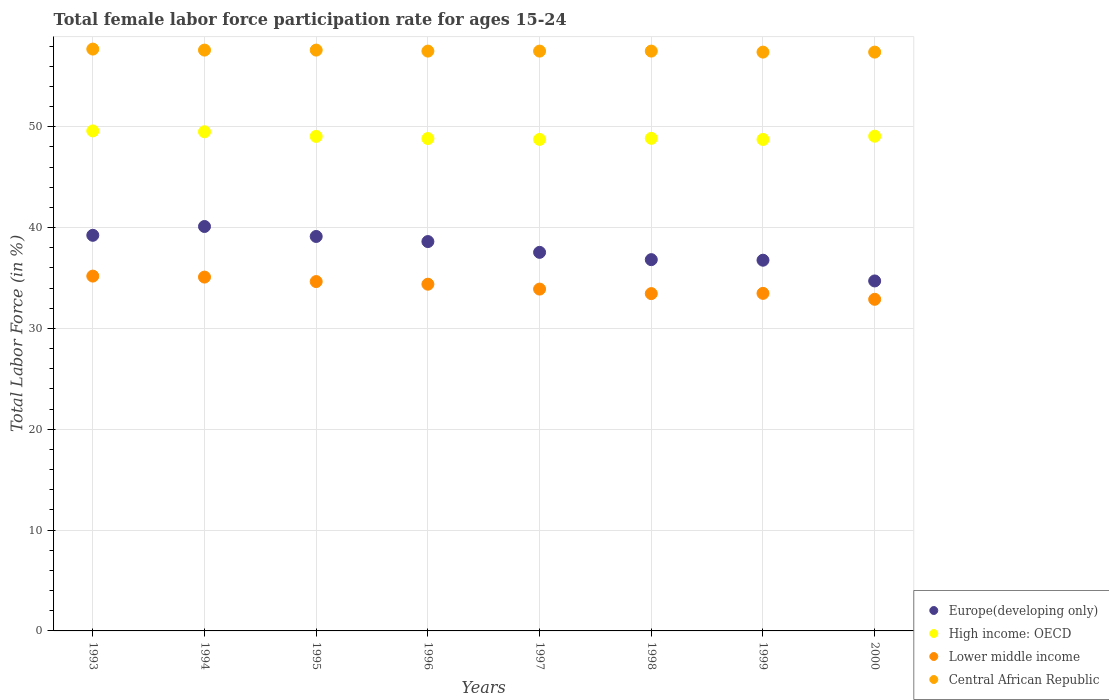Is the number of dotlines equal to the number of legend labels?
Give a very brief answer. Yes. What is the female labor force participation rate in High income: OECD in 1993?
Keep it short and to the point. 49.59. Across all years, what is the maximum female labor force participation rate in High income: OECD?
Offer a terse response. 49.59. Across all years, what is the minimum female labor force participation rate in Lower middle income?
Your answer should be very brief. 32.89. In which year was the female labor force participation rate in Central African Republic minimum?
Give a very brief answer. 1999. What is the total female labor force participation rate in High income: OECD in the graph?
Your answer should be compact. 392.35. What is the difference between the female labor force participation rate in Lower middle income in 1994 and that in 1996?
Your answer should be compact. 0.7. What is the difference between the female labor force participation rate in Europe(developing only) in 1993 and the female labor force participation rate in Lower middle income in 1996?
Your answer should be very brief. 4.85. What is the average female labor force participation rate in Europe(developing only) per year?
Keep it short and to the point. 37.86. In the year 1997, what is the difference between the female labor force participation rate in Lower middle income and female labor force participation rate in Central African Republic?
Your answer should be compact. -23.6. In how many years, is the female labor force participation rate in High income: OECD greater than 32 %?
Your answer should be very brief. 8. What is the ratio of the female labor force participation rate in Europe(developing only) in 1994 to that in 1996?
Provide a succinct answer. 1.04. Is the difference between the female labor force participation rate in Lower middle income in 1993 and 1996 greater than the difference between the female labor force participation rate in Central African Republic in 1993 and 1996?
Your response must be concise. Yes. What is the difference between the highest and the second highest female labor force participation rate in High income: OECD?
Ensure brevity in your answer.  0.08. What is the difference between the highest and the lowest female labor force participation rate in Lower middle income?
Your answer should be very brief. 2.3. In how many years, is the female labor force participation rate in Europe(developing only) greater than the average female labor force participation rate in Europe(developing only) taken over all years?
Make the answer very short. 4. Is it the case that in every year, the sum of the female labor force participation rate in Central African Republic and female labor force participation rate in Europe(developing only)  is greater than the female labor force participation rate in Lower middle income?
Ensure brevity in your answer.  Yes. Does the female labor force participation rate in Europe(developing only) monotonically increase over the years?
Ensure brevity in your answer.  No. Is the female labor force participation rate in Lower middle income strictly greater than the female labor force participation rate in Europe(developing only) over the years?
Give a very brief answer. No. Is the female labor force participation rate in Europe(developing only) strictly less than the female labor force participation rate in Central African Republic over the years?
Your answer should be compact. Yes. How many dotlines are there?
Your response must be concise. 4. Does the graph contain grids?
Provide a short and direct response. Yes. How are the legend labels stacked?
Keep it short and to the point. Vertical. What is the title of the graph?
Provide a short and direct response. Total female labor force participation rate for ages 15-24. Does "United Arab Emirates" appear as one of the legend labels in the graph?
Offer a very short reply. No. What is the Total Labor Force (in %) of Europe(developing only) in 1993?
Your response must be concise. 39.23. What is the Total Labor Force (in %) in High income: OECD in 1993?
Your response must be concise. 49.59. What is the Total Labor Force (in %) of Lower middle income in 1993?
Provide a short and direct response. 35.19. What is the Total Labor Force (in %) in Central African Republic in 1993?
Make the answer very short. 57.7. What is the Total Labor Force (in %) in Europe(developing only) in 1994?
Your answer should be very brief. 40.11. What is the Total Labor Force (in %) of High income: OECD in 1994?
Keep it short and to the point. 49.5. What is the Total Labor Force (in %) in Lower middle income in 1994?
Provide a succinct answer. 35.09. What is the Total Labor Force (in %) in Central African Republic in 1994?
Make the answer very short. 57.6. What is the Total Labor Force (in %) in Europe(developing only) in 1995?
Provide a succinct answer. 39.12. What is the Total Labor Force (in %) of High income: OECD in 1995?
Offer a terse response. 49.04. What is the Total Labor Force (in %) in Lower middle income in 1995?
Ensure brevity in your answer.  34.65. What is the Total Labor Force (in %) in Central African Republic in 1995?
Your answer should be compact. 57.6. What is the Total Labor Force (in %) of Europe(developing only) in 1996?
Your response must be concise. 38.61. What is the Total Labor Force (in %) in High income: OECD in 1996?
Your answer should be very brief. 48.83. What is the Total Labor Force (in %) in Lower middle income in 1996?
Your response must be concise. 34.38. What is the Total Labor Force (in %) of Central African Republic in 1996?
Provide a succinct answer. 57.5. What is the Total Labor Force (in %) of Europe(developing only) in 1997?
Ensure brevity in your answer.  37.54. What is the Total Labor Force (in %) in High income: OECD in 1997?
Provide a succinct answer. 48.74. What is the Total Labor Force (in %) in Lower middle income in 1997?
Ensure brevity in your answer.  33.9. What is the Total Labor Force (in %) in Central African Republic in 1997?
Offer a very short reply. 57.5. What is the Total Labor Force (in %) of Europe(developing only) in 1998?
Keep it short and to the point. 36.82. What is the Total Labor Force (in %) in High income: OECD in 1998?
Ensure brevity in your answer.  48.85. What is the Total Labor Force (in %) of Lower middle income in 1998?
Give a very brief answer. 33.45. What is the Total Labor Force (in %) of Central African Republic in 1998?
Make the answer very short. 57.5. What is the Total Labor Force (in %) in Europe(developing only) in 1999?
Ensure brevity in your answer.  36.76. What is the Total Labor Force (in %) in High income: OECD in 1999?
Ensure brevity in your answer.  48.74. What is the Total Labor Force (in %) of Lower middle income in 1999?
Make the answer very short. 33.48. What is the Total Labor Force (in %) in Central African Republic in 1999?
Make the answer very short. 57.4. What is the Total Labor Force (in %) of Europe(developing only) in 2000?
Offer a terse response. 34.71. What is the Total Labor Force (in %) in High income: OECD in 2000?
Offer a terse response. 49.06. What is the Total Labor Force (in %) of Lower middle income in 2000?
Your response must be concise. 32.89. What is the Total Labor Force (in %) in Central African Republic in 2000?
Offer a terse response. 57.4. Across all years, what is the maximum Total Labor Force (in %) of Europe(developing only)?
Give a very brief answer. 40.11. Across all years, what is the maximum Total Labor Force (in %) in High income: OECD?
Your answer should be compact. 49.59. Across all years, what is the maximum Total Labor Force (in %) in Lower middle income?
Provide a short and direct response. 35.19. Across all years, what is the maximum Total Labor Force (in %) in Central African Republic?
Offer a very short reply. 57.7. Across all years, what is the minimum Total Labor Force (in %) in Europe(developing only)?
Keep it short and to the point. 34.71. Across all years, what is the minimum Total Labor Force (in %) of High income: OECD?
Keep it short and to the point. 48.74. Across all years, what is the minimum Total Labor Force (in %) of Lower middle income?
Provide a succinct answer. 32.89. Across all years, what is the minimum Total Labor Force (in %) of Central African Republic?
Give a very brief answer. 57.4. What is the total Total Labor Force (in %) of Europe(developing only) in the graph?
Your answer should be very brief. 302.9. What is the total Total Labor Force (in %) in High income: OECD in the graph?
Provide a succinct answer. 392.35. What is the total Total Labor Force (in %) in Lower middle income in the graph?
Offer a very short reply. 273.02. What is the total Total Labor Force (in %) in Central African Republic in the graph?
Ensure brevity in your answer.  460.2. What is the difference between the Total Labor Force (in %) of Europe(developing only) in 1993 and that in 1994?
Your answer should be very brief. -0.87. What is the difference between the Total Labor Force (in %) of High income: OECD in 1993 and that in 1994?
Provide a short and direct response. 0.08. What is the difference between the Total Labor Force (in %) of Lower middle income in 1993 and that in 1994?
Give a very brief answer. 0.1. What is the difference between the Total Labor Force (in %) of Central African Republic in 1993 and that in 1994?
Your answer should be compact. 0.1. What is the difference between the Total Labor Force (in %) of Europe(developing only) in 1993 and that in 1995?
Your answer should be compact. 0.11. What is the difference between the Total Labor Force (in %) in High income: OECD in 1993 and that in 1995?
Offer a terse response. 0.55. What is the difference between the Total Labor Force (in %) of Lower middle income in 1993 and that in 1995?
Your answer should be compact. 0.54. What is the difference between the Total Labor Force (in %) in Central African Republic in 1993 and that in 1995?
Provide a short and direct response. 0.1. What is the difference between the Total Labor Force (in %) of Europe(developing only) in 1993 and that in 1996?
Give a very brief answer. 0.62. What is the difference between the Total Labor Force (in %) of High income: OECD in 1993 and that in 1996?
Provide a short and direct response. 0.76. What is the difference between the Total Labor Force (in %) in Lower middle income in 1993 and that in 1996?
Offer a terse response. 0.8. What is the difference between the Total Labor Force (in %) of Europe(developing only) in 1993 and that in 1997?
Give a very brief answer. 1.69. What is the difference between the Total Labor Force (in %) in High income: OECD in 1993 and that in 1997?
Give a very brief answer. 0.84. What is the difference between the Total Labor Force (in %) of Lower middle income in 1993 and that in 1997?
Provide a succinct answer. 1.29. What is the difference between the Total Labor Force (in %) of Central African Republic in 1993 and that in 1997?
Your response must be concise. 0.2. What is the difference between the Total Labor Force (in %) in Europe(developing only) in 1993 and that in 1998?
Your response must be concise. 2.41. What is the difference between the Total Labor Force (in %) of High income: OECD in 1993 and that in 1998?
Your answer should be very brief. 0.74. What is the difference between the Total Labor Force (in %) in Lower middle income in 1993 and that in 1998?
Your answer should be very brief. 1.74. What is the difference between the Total Labor Force (in %) in Europe(developing only) in 1993 and that in 1999?
Offer a very short reply. 2.47. What is the difference between the Total Labor Force (in %) of High income: OECD in 1993 and that in 1999?
Make the answer very short. 0.85. What is the difference between the Total Labor Force (in %) in Lower middle income in 1993 and that in 1999?
Provide a succinct answer. 1.71. What is the difference between the Total Labor Force (in %) in Europe(developing only) in 1993 and that in 2000?
Keep it short and to the point. 4.53. What is the difference between the Total Labor Force (in %) in High income: OECD in 1993 and that in 2000?
Ensure brevity in your answer.  0.53. What is the difference between the Total Labor Force (in %) in Lower middle income in 1993 and that in 2000?
Provide a short and direct response. 2.3. What is the difference between the Total Labor Force (in %) in Europe(developing only) in 1994 and that in 1995?
Provide a short and direct response. 0.99. What is the difference between the Total Labor Force (in %) in High income: OECD in 1994 and that in 1995?
Provide a short and direct response. 0.46. What is the difference between the Total Labor Force (in %) of Lower middle income in 1994 and that in 1995?
Give a very brief answer. 0.44. What is the difference between the Total Labor Force (in %) of Central African Republic in 1994 and that in 1995?
Ensure brevity in your answer.  0. What is the difference between the Total Labor Force (in %) of Europe(developing only) in 1994 and that in 1996?
Offer a very short reply. 1.5. What is the difference between the Total Labor Force (in %) of High income: OECD in 1994 and that in 1996?
Offer a very short reply. 0.67. What is the difference between the Total Labor Force (in %) in Lower middle income in 1994 and that in 1996?
Give a very brief answer. 0.7. What is the difference between the Total Labor Force (in %) of Central African Republic in 1994 and that in 1996?
Your answer should be compact. 0.1. What is the difference between the Total Labor Force (in %) of Europe(developing only) in 1994 and that in 1997?
Your answer should be very brief. 2.56. What is the difference between the Total Labor Force (in %) of High income: OECD in 1994 and that in 1997?
Offer a terse response. 0.76. What is the difference between the Total Labor Force (in %) of Lower middle income in 1994 and that in 1997?
Give a very brief answer. 1.19. What is the difference between the Total Labor Force (in %) of Europe(developing only) in 1994 and that in 1998?
Make the answer very short. 3.29. What is the difference between the Total Labor Force (in %) in High income: OECD in 1994 and that in 1998?
Your answer should be compact. 0.65. What is the difference between the Total Labor Force (in %) in Lower middle income in 1994 and that in 1998?
Provide a succinct answer. 1.64. What is the difference between the Total Labor Force (in %) of Europe(developing only) in 1994 and that in 1999?
Provide a short and direct response. 3.34. What is the difference between the Total Labor Force (in %) in High income: OECD in 1994 and that in 1999?
Keep it short and to the point. 0.76. What is the difference between the Total Labor Force (in %) in Lower middle income in 1994 and that in 1999?
Give a very brief answer. 1.61. What is the difference between the Total Labor Force (in %) in Europe(developing only) in 1994 and that in 2000?
Offer a very short reply. 5.4. What is the difference between the Total Labor Force (in %) in High income: OECD in 1994 and that in 2000?
Provide a short and direct response. 0.45. What is the difference between the Total Labor Force (in %) of Lower middle income in 1994 and that in 2000?
Your answer should be compact. 2.2. What is the difference between the Total Labor Force (in %) of Central African Republic in 1994 and that in 2000?
Provide a succinct answer. 0.2. What is the difference between the Total Labor Force (in %) of Europe(developing only) in 1995 and that in 1996?
Offer a terse response. 0.51. What is the difference between the Total Labor Force (in %) of High income: OECD in 1995 and that in 1996?
Keep it short and to the point. 0.21. What is the difference between the Total Labor Force (in %) of Lower middle income in 1995 and that in 1996?
Provide a short and direct response. 0.26. What is the difference between the Total Labor Force (in %) in Central African Republic in 1995 and that in 1996?
Offer a terse response. 0.1. What is the difference between the Total Labor Force (in %) in Europe(developing only) in 1995 and that in 1997?
Make the answer very short. 1.58. What is the difference between the Total Labor Force (in %) of High income: OECD in 1995 and that in 1997?
Your response must be concise. 0.3. What is the difference between the Total Labor Force (in %) in Lower middle income in 1995 and that in 1997?
Ensure brevity in your answer.  0.75. What is the difference between the Total Labor Force (in %) of Central African Republic in 1995 and that in 1997?
Keep it short and to the point. 0.1. What is the difference between the Total Labor Force (in %) in Europe(developing only) in 1995 and that in 1998?
Give a very brief answer. 2.3. What is the difference between the Total Labor Force (in %) of High income: OECD in 1995 and that in 1998?
Make the answer very short. 0.19. What is the difference between the Total Labor Force (in %) of Lower middle income in 1995 and that in 1998?
Give a very brief answer. 1.19. What is the difference between the Total Labor Force (in %) in Europe(developing only) in 1995 and that in 1999?
Your answer should be very brief. 2.35. What is the difference between the Total Labor Force (in %) of High income: OECD in 1995 and that in 1999?
Offer a very short reply. 0.3. What is the difference between the Total Labor Force (in %) in Lower middle income in 1995 and that in 1999?
Your answer should be compact. 1.17. What is the difference between the Total Labor Force (in %) in Europe(developing only) in 1995 and that in 2000?
Make the answer very short. 4.41. What is the difference between the Total Labor Force (in %) of High income: OECD in 1995 and that in 2000?
Make the answer very short. -0.02. What is the difference between the Total Labor Force (in %) of Lower middle income in 1995 and that in 2000?
Offer a very short reply. 1.76. What is the difference between the Total Labor Force (in %) of Europe(developing only) in 1996 and that in 1997?
Give a very brief answer. 1.07. What is the difference between the Total Labor Force (in %) of High income: OECD in 1996 and that in 1997?
Make the answer very short. 0.08. What is the difference between the Total Labor Force (in %) of Lower middle income in 1996 and that in 1997?
Your answer should be compact. 0.49. What is the difference between the Total Labor Force (in %) of Central African Republic in 1996 and that in 1997?
Your response must be concise. 0. What is the difference between the Total Labor Force (in %) of Europe(developing only) in 1996 and that in 1998?
Your answer should be very brief. 1.79. What is the difference between the Total Labor Force (in %) in High income: OECD in 1996 and that in 1998?
Offer a very short reply. -0.02. What is the difference between the Total Labor Force (in %) in Lower middle income in 1996 and that in 1998?
Ensure brevity in your answer.  0.93. What is the difference between the Total Labor Force (in %) in Central African Republic in 1996 and that in 1998?
Offer a terse response. 0. What is the difference between the Total Labor Force (in %) of Europe(developing only) in 1996 and that in 1999?
Provide a succinct answer. 1.85. What is the difference between the Total Labor Force (in %) of High income: OECD in 1996 and that in 1999?
Give a very brief answer. 0.09. What is the difference between the Total Labor Force (in %) in Lower middle income in 1996 and that in 1999?
Keep it short and to the point. 0.91. What is the difference between the Total Labor Force (in %) of Central African Republic in 1996 and that in 1999?
Give a very brief answer. 0.1. What is the difference between the Total Labor Force (in %) in Europe(developing only) in 1996 and that in 2000?
Offer a very short reply. 3.9. What is the difference between the Total Labor Force (in %) of High income: OECD in 1996 and that in 2000?
Provide a short and direct response. -0.23. What is the difference between the Total Labor Force (in %) in Lower middle income in 1996 and that in 2000?
Ensure brevity in your answer.  1.5. What is the difference between the Total Labor Force (in %) in Europe(developing only) in 1997 and that in 1998?
Your answer should be very brief. 0.72. What is the difference between the Total Labor Force (in %) in High income: OECD in 1997 and that in 1998?
Offer a very short reply. -0.11. What is the difference between the Total Labor Force (in %) of Lower middle income in 1997 and that in 1998?
Ensure brevity in your answer.  0.45. What is the difference between the Total Labor Force (in %) in Central African Republic in 1997 and that in 1998?
Your answer should be very brief. 0. What is the difference between the Total Labor Force (in %) in Europe(developing only) in 1997 and that in 1999?
Offer a very short reply. 0.78. What is the difference between the Total Labor Force (in %) in High income: OECD in 1997 and that in 1999?
Your response must be concise. 0.01. What is the difference between the Total Labor Force (in %) of Lower middle income in 1997 and that in 1999?
Give a very brief answer. 0.42. What is the difference between the Total Labor Force (in %) in Europe(developing only) in 1997 and that in 2000?
Make the answer very short. 2.84. What is the difference between the Total Labor Force (in %) of High income: OECD in 1997 and that in 2000?
Make the answer very short. -0.31. What is the difference between the Total Labor Force (in %) of Lower middle income in 1997 and that in 2000?
Make the answer very short. 1.01. What is the difference between the Total Labor Force (in %) in Europe(developing only) in 1998 and that in 1999?
Ensure brevity in your answer.  0.06. What is the difference between the Total Labor Force (in %) in High income: OECD in 1998 and that in 1999?
Your response must be concise. 0.11. What is the difference between the Total Labor Force (in %) in Lower middle income in 1998 and that in 1999?
Provide a short and direct response. -0.02. What is the difference between the Total Labor Force (in %) of Europe(developing only) in 1998 and that in 2000?
Provide a succinct answer. 2.11. What is the difference between the Total Labor Force (in %) in High income: OECD in 1998 and that in 2000?
Your answer should be very brief. -0.21. What is the difference between the Total Labor Force (in %) in Lower middle income in 1998 and that in 2000?
Your answer should be very brief. 0.56. What is the difference between the Total Labor Force (in %) of Central African Republic in 1998 and that in 2000?
Ensure brevity in your answer.  0.1. What is the difference between the Total Labor Force (in %) in Europe(developing only) in 1999 and that in 2000?
Make the answer very short. 2.06. What is the difference between the Total Labor Force (in %) in High income: OECD in 1999 and that in 2000?
Provide a succinct answer. -0.32. What is the difference between the Total Labor Force (in %) in Lower middle income in 1999 and that in 2000?
Keep it short and to the point. 0.59. What is the difference between the Total Labor Force (in %) in Europe(developing only) in 1993 and the Total Labor Force (in %) in High income: OECD in 1994?
Ensure brevity in your answer.  -10.27. What is the difference between the Total Labor Force (in %) in Europe(developing only) in 1993 and the Total Labor Force (in %) in Lower middle income in 1994?
Ensure brevity in your answer.  4.14. What is the difference between the Total Labor Force (in %) of Europe(developing only) in 1993 and the Total Labor Force (in %) of Central African Republic in 1994?
Your answer should be compact. -18.37. What is the difference between the Total Labor Force (in %) in High income: OECD in 1993 and the Total Labor Force (in %) in Lower middle income in 1994?
Your answer should be compact. 14.5. What is the difference between the Total Labor Force (in %) in High income: OECD in 1993 and the Total Labor Force (in %) in Central African Republic in 1994?
Offer a terse response. -8.01. What is the difference between the Total Labor Force (in %) in Lower middle income in 1993 and the Total Labor Force (in %) in Central African Republic in 1994?
Give a very brief answer. -22.41. What is the difference between the Total Labor Force (in %) in Europe(developing only) in 1993 and the Total Labor Force (in %) in High income: OECD in 1995?
Your answer should be compact. -9.81. What is the difference between the Total Labor Force (in %) of Europe(developing only) in 1993 and the Total Labor Force (in %) of Lower middle income in 1995?
Provide a succinct answer. 4.59. What is the difference between the Total Labor Force (in %) in Europe(developing only) in 1993 and the Total Labor Force (in %) in Central African Republic in 1995?
Give a very brief answer. -18.37. What is the difference between the Total Labor Force (in %) of High income: OECD in 1993 and the Total Labor Force (in %) of Lower middle income in 1995?
Offer a terse response. 14.94. What is the difference between the Total Labor Force (in %) in High income: OECD in 1993 and the Total Labor Force (in %) in Central African Republic in 1995?
Offer a terse response. -8.01. What is the difference between the Total Labor Force (in %) of Lower middle income in 1993 and the Total Labor Force (in %) of Central African Republic in 1995?
Make the answer very short. -22.41. What is the difference between the Total Labor Force (in %) of Europe(developing only) in 1993 and the Total Labor Force (in %) of High income: OECD in 1996?
Give a very brief answer. -9.6. What is the difference between the Total Labor Force (in %) of Europe(developing only) in 1993 and the Total Labor Force (in %) of Lower middle income in 1996?
Make the answer very short. 4.85. What is the difference between the Total Labor Force (in %) in Europe(developing only) in 1993 and the Total Labor Force (in %) in Central African Republic in 1996?
Offer a very short reply. -18.27. What is the difference between the Total Labor Force (in %) of High income: OECD in 1993 and the Total Labor Force (in %) of Lower middle income in 1996?
Offer a terse response. 15.2. What is the difference between the Total Labor Force (in %) in High income: OECD in 1993 and the Total Labor Force (in %) in Central African Republic in 1996?
Give a very brief answer. -7.91. What is the difference between the Total Labor Force (in %) in Lower middle income in 1993 and the Total Labor Force (in %) in Central African Republic in 1996?
Your answer should be very brief. -22.31. What is the difference between the Total Labor Force (in %) of Europe(developing only) in 1993 and the Total Labor Force (in %) of High income: OECD in 1997?
Make the answer very short. -9.51. What is the difference between the Total Labor Force (in %) in Europe(developing only) in 1993 and the Total Labor Force (in %) in Lower middle income in 1997?
Offer a very short reply. 5.33. What is the difference between the Total Labor Force (in %) in Europe(developing only) in 1993 and the Total Labor Force (in %) in Central African Republic in 1997?
Your answer should be very brief. -18.27. What is the difference between the Total Labor Force (in %) of High income: OECD in 1993 and the Total Labor Force (in %) of Lower middle income in 1997?
Offer a terse response. 15.69. What is the difference between the Total Labor Force (in %) of High income: OECD in 1993 and the Total Labor Force (in %) of Central African Republic in 1997?
Ensure brevity in your answer.  -7.91. What is the difference between the Total Labor Force (in %) in Lower middle income in 1993 and the Total Labor Force (in %) in Central African Republic in 1997?
Provide a short and direct response. -22.31. What is the difference between the Total Labor Force (in %) of Europe(developing only) in 1993 and the Total Labor Force (in %) of High income: OECD in 1998?
Offer a very short reply. -9.62. What is the difference between the Total Labor Force (in %) in Europe(developing only) in 1993 and the Total Labor Force (in %) in Lower middle income in 1998?
Provide a succinct answer. 5.78. What is the difference between the Total Labor Force (in %) in Europe(developing only) in 1993 and the Total Labor Force (in %) in Central African Republic in 1998?
Your answer should be compact. -18.27. What is the difference between the Total Labor Force (in %) in High income: OECD in 1993 and the Total Labor Force (in %) in Lower middle income in 1998?
Keep it short and to the point. 16.14. What is the difference between the Total Labor Force (in %) in High income: OECD in 1993 and the Total Labor Force (in %) in Central African Republic in 1998?
Provide a succinct answer. -7.91. What is the difference between the Total Labor Force (in %) of Lower middle income in 1993 and the Total Labor Force (in %) of Central African Republic in 1998?
Offer a very short reply. -22.31. What is the difference between the Total Labor Force (in %) in Europe(developing only) in 1993 and the Total Labor Force (in %) in High income: OECD in 1999?
Your answer should be very brief. -9.51. What is the difference between the Total Labor Force (in %) in Europe(developing only) in 1993 and the Total Labor Force (in %) in Lower middle income in 1999?
Provide a short and direct response. 5.76. What is the difference between the Total Labor Force (in %) in Europe(developing only) in 1993 and the Total Labor Force (in %) in Central African Republic in 1999?
Ensure brevity in your answer.  -18.17. What is the difference between the Total Labor Force (in %) in High income: OECD in 1993 and the Total Labor Force (in %) in Lower middle income in 1999?
Provide a succinct answer. 16.11. What is the difference between the Total Labor Force (in %) in High income: OECD in 1993 and the Total Labor Force (in %) in Central African Republic in 1999?
Make the answer very short. -7.81. What is the difference between the Total Labor Force (in %) of Lower middle income in 1993 and the Total Labor Force (in %) of Central African Republic in 1999?
Give a very brief answer. -22.21. What is the difference between the Total Labor Force (in %) in Europe(developing only) in 1993 and the Total Labor Force (in %) in High income: OECD in 2000?
Your answer should be very brief. -9.83. What is the difference between the Total Labor Force (in %) of Europe(developing only) in 1993 and the Total Labor Force (in %) of Lower middle income in 2000?
Offer a very short reply. 6.35. What is the difference between the Total Labor Force (in %) in Europe(developing only) in 1993 and the Total Labor Force (in %) in Central African Republic in 2000?
Offer a very short reply. -18.17. What is the difference between the Total Labor Force (in %) of High income: OECD in 1993 and the Total Labor Force (in %) of Central African Republic in 2000?
Offer a very short reply. -7.81. What is the difference between the Total Labor Force (in %) in Lower middle income in 1993 and the Total Labor Force (in %) in Central African Republic in 2000?
Provide a short and direct response. -22.21. What is the difference between the Total Labor Force (in %) of Europe(developing only) in 1994 and the Total Labor Force (in %) of High income: OECD in 1995?
Ensure brevity in your answer.  -8.93. What is the difference between the Total Labor Force (in %) in Europe(developing only) in 1994 and the Total Labor Force (in %) in Lower middle income in 1995?
Your answer should be very brief. 5.46. What is the difference between the Total Labor Force (in %) in Europe(developing only) in 1994 and the Total Labor Force (in %) in Central African Republic in 1995?
Your answer should be very brief. -17.49. What is the difference between the Total Labor Force (in %) in High income: OECD in 1994 and the Total Labor Force (in %) in Lower middle income in 1995?
Your response must be concise. 14.86. What is the difference between the Total Labor Force (in %) in High income: OECD in 1994 and the Total Labor Force (in %) in Central African Republic in 1995?
Your response must be concise. -8.1. What is the difference between the Total Labor Force (in %) of Lower middle income in 1994 and the Total Labor Force (in %) of Central African Republic in 1995?
Give a very brief answer. -22.51. What is the difference between the Total Labor Force (in %) of Europe(developing only) in 1994 and the Total Labor Force (in %) of High income: OECD in 1996?
Offer a very short reply. -8.72. What is the difference between the Total Labor Force (in %) of Europe(developing only) in 1994 and the Total Labor Force (in %) of Lower middle income in 1996?
Your answer should be very brief. 5.72. What is the difference between the Total Labor Force (in %) of Europe(developing only) in 1994 and the Total Labor Force (in %) of Central African Republic in 1996?
Keep it short and to the point. -17.39. What is the difference between the Total Labor Force (in %) in High income: OECD in 1994 and the Total Labor Force (in %) in Lower middle income in 1996?
Offer a very short reply. 15.12. What is the difference between the Total Labor Force (in %) of High income: OECD in 1994 and the Total Labor Force (in %) of Central African Republic in 1996?
Provide a succinct answer. -8. What is the difference between the Total Labor Force (in %) in Lower middle income in 1994 and the Total Labor Force (in %) in Central African Republic in 1996?
Your response must be concise. -22.41. What is the difference between the Total Labor Force (in %) in Europe(developing only) in 1994 and the Total Labor Force (in %) in High income: OECD in 1997?
Keep it short and to the point. -8.64. What is the difference between the Total Labor Force (in %) in Europe(developing only) in 1994 and the Total Labor Force (in %) in Lower middle income in 1997?
Ensure brevity in your answer.  6.21. What is the difference between the Total Labor Force (in %) of Europe(developing only) in 1994 and the Total Labor Force (in %) of Central African Republic in 1997?
Keep it short and to the point. -17.39. What is the difference between the Total Labor Force (in %) in High income: OECD in 1994 and the Total Labor Force (in %) in Lower middle income in 1997?
Provide a short and direct response. 15.6. What is the difference between the Total Labor Force (in %) in High income: OECD in 1994 and the Total Labor Force (in %) in Central African Republic in 1997?
Provide a succinct answer. -8. What is the difference between the Total Labor Force (in %) of Lower middle income in 1994 and the Total Labor Force (in %) of Central African Republic in 1997?
Offer a very short reply. -22.41. What is the difference between the Total Labor Force (in %) of Europe(developing only) in 1994 and the Total Labor Force (in %) of High income: OECD in 1998?
Your answer should be compact. -8.74. What is the difference between the Total Labor Force (in %) of Europe(developing only) in 1994 and the Total Labor Force (in %) of Lower middle income in 1998?
Provide a short and direct response. 6.66. What is the difference between the Total Labor Force (in %) in Europe(developing only) in 1994 and the Total Labor Force (in %) in Central African Republic in 1998?
Make the answer very short. -17.39. What is the difference between the Total Labor Force (in %) in High income: OECD in 1994 and the Total Labor Force (in %) in Lower middle income in 1998?
Your answer should be very brief. 16.05. What is the difference between the Total Labor Force (in %) of High income: OECD in 1994 and the Total Labor Force (in %) of Central African Republic in 1998?
Make the answer very short. -8. What is the difference between the Total Labor Force (in %) of Lower middle income in 1994 and the Total Labor Force (in %) of Central African Republic in 1998?
Provide a short and direct response. -22.41. What is the difference between the Total Labor Force (in %) in Europe(developing only) in 1994 and the Total Labor Force (in %) in High income: OECD in 1999?
Give a very brief answer. -8.63. What is the difference between the Total Labor Force (in %) in Europe(developing only) in 1994 and the Total Labor Force (in %) in Lower middle income in 1999?
Keep it short and to the point. 6.63. What is the difference between the Total Labor Force (in %) of Europe(developing only) in 1994 and the Total Labor Force (in %) of Central African Republic in 1999?
Provide a short and direct response. -17.29. What is the difference between the Total Labor Force (in %) of High income: OECD in 1994 and the Total Labor Force (in %) of Lower middle income in 1999?
Offer a very short reply. 16.03. What is the difference between the Total Labor Force (in %) in High income: OECD in 1994 and the Total Labor Force (in %) in Central African Republic in 1999?
Provide a succinct answer. -7.9. What is the difference between the Total Labor Force (in %) in Lower middle income in 1994 and the Total Labor Force (in %) in Central African Republic in 1999?
Your response must be concise. -22.31. What is the difference between the Total Labor Force (in %) of Europe(developing only) in 1994 and the Total Labor Force (in %) of High income: OECD in 2000?
Provide a short and direct response. -8.95. What is the difference between the Total Labor Force (in %) in Europe(developing only) in 1994 and the Total Labor Force (in %) in Lower middle income in 2000?
Your response must be concise. 7.22. What is the difference between the Total Labor Force (in %) of Europe(developing only) in 1994 and the Total Labor Force (in %) of Central African Republic in 2000?
Offer a very short reply. -17.29. What is the difference between the Total Labor Force (in %) in High income: OECD in 1994 and the Total Labor Force (in %) in Lower middle income in 2000?
Offer a terse response. 16.62. What is the difference between the Total Labor Force (in %) of High income: OECD in 1994 and the Total Labor Force (in %) of Central African Republic in 2000?
Provide a succinct answer. -7.9. What is the difference between the Total Labor Force (in %) in Lower middle income in 1994 and the Total Labor Force (in %) in Central African Republic in 2000?
Make the answer very short. -22.31. What is the difference between the Total Labor Force (in %) in Europe(developing only) in 1995 and the Total Labor Force (in %) in High income: OECD in 1996?
Provide a short and direct response. -9.71. What is the difference between the Total Labor Force (in %) in Europe(developing only) in 1995 and the Total Labor Force (in %) in Lower middle income in 1996?
Offer a terse response. 4.73. What is the difference between the Total Labor Force (in %) in Europe(developing only) in 1995 and the Total Labor Force (in %) in Central African Republic in 1996?
Keep it short and to the point. -18.38. What is the difference between the Total Labor Force (in %) in High income: OECD in 1995 and the Total Labor Force (in %) in Lower middle income in 1996?
Your answer should be very brief. 14.66. What is the difference between the Total Labor Force (in %) of High income: OECD in 1995 and the Total Labor Force (in %) of Central African Republic in 1996?
Provide a short and direct response. -8.46. What is the difference between the Total Labor Force (in %) in Lower middle income in 1995 and the Total Labor Force (in %) in Central African Republic in 1996?
Provide a succinct answer. -22.85. What is the difference between the Total Labor Force (in %) in Europe(developing only) in 1995 and the Total Labor Force (in %) in High income: OECD in 1997?
Provide a succinct answer. -9.63. What is the difference between the Total Labor Force (in %) in Europe(developing only) in 1995 and the Total Labor Force (in %) in Lower middle income in 1997?
Provide a short and direct response. 5.22. What is the difference between the Total Labor Force (in %) in Europe(developing only) in 1995 and the Total Labor Force (in %) in Central African Republic in 1997?
Ensure brevity in your answer.  -18.38. What is the difference between the Total Labor Force (in %) in High income: OECD in 1995 and the Total Labor Force (in %) in Lower middle income in 1997?
Make the answer very short. 15.14. What is the difference between the Total Labor Force (in %) in High income: OECD in 1995 and the Total Labor Force (in %) in Central African Republic in 1997?
Offer a very short reply. -8.46. What is the difference between the Total Labor Force (in %) in Lower middle income in 1995 and the Total Labor Force (in %) in Central African Republic in 1997?
Your answer should be very brief. -22.85. What is the difference between the Total Labor Force (in %) in Europe(developing only) in 1995 and the Total Labor Force (in %) in High income: OECD in 1998?
Provide a short and direct response. -9.73. What is the difference between the Total Labor Force (in %) in Europe(developing only) in 1995 and the Total Labor Force (in %) in Lower middle income in 1998?
Your answer should be compact. 5.67. What is the difference between the Total Labor Force (in %) in Europe(developing only) in 1995 and the Total Labor Force (in %) in Central African Republic in 1998?
Ensure brevity in your answer.  -18.38. What is the difference between the Total Labor Force (in %) in High income: OECD in 1995 and the Total Labor Force (in %) in Lower middle income in 1998?
Offer a terse response. 15.59. What is the difference between the Total Labor Force (in %) of High income: OECD in 1995 and the Total Labor Force (in %) of Central African Republic in 1998?
Ensure brevity in your answer.  -8.46. What is the difference between the Total Labor Force (in %) in Lower middle income in 1995 and the Total Labor Force (in %) in Central African Republic in 1998?
Offer a very short reply. -22.85. What is the difference between the Total Labor Force (in %) of Europe(developing only) in 1995 and the Total Labor Force (in %) of High income: OECD in 1999?
Give a very brief answer. -9.62. What is the difference between the Total Labor Force (in %) in Europe(developing only) in 1995 and the Total Labor Force (in %) in Lower middle income in 1999?
Your response must be concise. 5.64. What is the difference between the Total Labor Force (in %) of Europe(developing only) in 1995 and the Total Labor Force (in %) of Central African Republic in 1999?
Make the answer very short. -18.28. What is the difference between the Total Labor Force (in %) in High income: OECD in 1995 and the Total Labor Force (in %) in Lower middle income in 1999?
Your answer should be very brief. 15.56. What is the difference between the Total Labor Force (in %) of High income: OECD in 1995 and the Total Labor Force (in %) of Central African Republic in 1999?
Provide a short and direct response. -8.36. What is the difference between the Total Labor Force (in %) of Lower middle income in 1995 and the Total Labor Force (in %) of Central African Republic in 1999?
Offer a terse response. -22.75. What is the difference between the Total Labor Force (in %) in Europe(developing only) in 1995 and the Total Labor Force (in %) in High income: OECD in 2000?
Your answer should be compact. -9.94. What is the difference between the Total Labor Force (in %) in Europe(developing only) in 1995 and the Total Labor Force (in %) in Lower middle income in 2000?
Offer a terse response. 6.23. What is the difference between the Total Labor Force (in %) of Europe(developing only) in 1995 and the Total Labor Force (in %) of Central African Republic in 2000?
Your response must be concise. -18.28. What is the difference between the Total Labor Force (in %) in High income: OECD in 1995 and the Total Labor Force (in %) in Lower middle income in 2000?
Your response must be concise. 16.15. What is the difference between the Total Labor Force (in %) in High income: OECD in 1995 and the Total Labor Force (in %) in Central African Republic in 2000?
Your response must be concise. -8.36. What is the difference between the Total Labor Force (in %) in Lower middle income in 1995 and the Total Labor Force (in %) in Central African Republic in 2000?
Your answer should be compact. -22.75. What is the difference between the Total Labor Force (in %) in Europe(developing only) in 1996 and the Total Labor Force (in %) in High income: OECD in 1997?
Give a very brief answer. -10.13. What is the difference between the Total Labor Force (in %) of Europe(developing only) in 1996 and the Total Labor Force (in %) of Lower middle income in 1997?
Give a very brief answer. 4.71. What is the difference between the Total Labor Force (in %) of Europe(developing only) in 1996 and the Total Labor Force (in %) of Central African Republic in 1997?
Keep it short and to the point. -18.89. What is the difference between the Total Labor Force (in %) of High income: OECD in 1996 and the Total Labor Force (in %) of Lower middle income in 1997?
Provide a succinct answer. 14.93. What is the difference between the Total Labor Force (in %) in High income: OECD in 1996 and the Total Labor Force (in %) in Central African Republic in 1997?
Provide a short and direct response. -8.67. What is the difference between the Total Labor Force (in %) in Lower middle income in 1996 and the Total Labor Force (in %) in Central African Republic in 1997?
Provide a succinct answer. -23.12. What is the difference between the Total Labor Force (in %) of Europe(developing only) in 1996 and the Total Labor Force (in %) of High income: OECD in 1998?
Provide a succinct answer. -10.24. What is the difference between the Total Labor Force (in %) in Europe(developing only) in 1996 and the Total Labor Force (in %) in Lower middle income in 1998?
Your response must be concise. 5.16. What is the difference between the Total Labor Force (in %) of Europe(developing only) in 1996 and the Total Labor Force (in %) of Central African Republic in 1998?
Your answer should be compact. -18.89. What is the difference between the Total Labor Force (in %) of High income: OECD in 1996 and the Total Labor Force (in %) of Lower middle income in 1998?
Provide a succinct answer. 15.38. What is the difference between the Total Labor Force (in %) in High income: OECD in 1996 and the Total Labor Force (in %) in Central African Republic in 1998?
Provide a succinct answer. -8.67. What is the difference between the Total Labor Force (in %) of Lower middle income in 1996 and the Total Labor Force (in %) of Central African Republic in 1998?
Your answer should be very brief. -23.12. What is the difference between the Total Labor Force (in %) in Europe(developing only) in 1996 and the Total Labor Force (in %) in High income: OECD in 1999?
Your answer should be compact. -10.13. What is the difference between the Total Labor Force (in %) in Europe(developing only) in 1996 and the Total Labor Force (in %) in Lower middle income in 1999?
Provide a succinct answer. 5.14. What is the difference between the Total Labor Force (in %) of Europe(developing only) in 1996 and the Total Labor Force (in %) of Central African Republic in 1999?
Provide a short and direct response. -18.79. What is the difference between the Total Labor Force (in %) of High income: OECD in 1996 and the Total Labor Force (in %) of Lower middle income in 1999?
Your answer should be compact. 15.35. What is the difference between the Total Labor Force (in %) in High income: OECD in 1996 and the Total Labor Force (in %) in Central African Republic in 1999?
Ensure brevity in your answer.  -8.57. What is the difference between the Total Labor Force (in %) in Lower middle income in 1996 and the Total Labor Force (in %) in Central African Republic in 1999?
Make the answer very short. -23.02. What is the difference between the Total Labor Force (in %) of Europe(developing only) in 1996 and the Total Labor Force (in %) of High income: OECD in 2000?
Your response must be concise. -10.45. What is the difference between the Total Labor Force (in %) in Europe(developing only) in 1996 and the Total Labor Force (in %) in Lower middle income in 2000?
Provide a succinct answer. 5.73. What is the difference between the Total Labor Force (in %) of Europe(developing only) in 1996 and the Total Labor Force (in %) of Central African Republic in 2000?
Provide a short and direct response. -18.79. What is the difference between the Total Labor Force (in %) of High income: OECD in 1996 and the Total Labor Force (in %) of Lower middle income in 2000?
Keep it short and to the point. 15.94. What is the difference between the Total Labor Force (in %) of High income: OECD in 1996 and the Total Labor Force (in %) of Central African Republic in 2000?
Offer a very short reply. -8.57. What is the difference between the Total Labor Force (in %) in Lower middle income in 1996 and the Total Labor Force (in %) in Central African Republic in 2000?
Your answer should be compact. -23.02. What is the difference between the Total Labor Force (in %) in Europe(developing only) in 1997 and the Total Labor Force (in %) in High income: OECD in 1998?
Your answer should be compact. -11.31. What is the difference between the Total Labor Force (in %) in Europe(developing only) in 1997 and the Total Labor Force (in %) in Lower middle income in 1998?
Your response must be concise. 4.09. What is the difference between the Total Labor Force (in %) of Europe(developing only) in 1997 and the Total Labor Force (in %) of Central African Republic in 1998?
Ensure brevity in your answer.  -19.96. What is the difference between the Total Labor Force (in %) of High income: OECD in 1997 and the Total Labor Force (in %) of Lower middle income in 1998?
Provide a short and direct response. 15.29. What is the difference between the Total Labor Force (in %) of High income: OECD in 1997 and the Total Labor Force (in %) of Central African Republic in 1998?
Ensure brevity in your answer.  -8.76. What is the difference between the Total Labor Force (in %) in Lower middle income in 1997 and the Total Labor Force (in %) in Central African Republic in 1998?
Offer a very short reply. -23.6. What is the difference between the Total Labor Force (in %) of Europe(developing only) in 1997 and the Total Labor Force (in %) of High income: OECD in 1999?
Your answer should be very brief. -11.2. What is the difference between the Total Labor Force (in %) in Europe(developing only) in 1997 and the Total Labor Force (in %) in Lower middle income in 1999?
Provide a succinct answer. 4.07. What is the difference between the Total Labor Force (in %) of Europe(developing only) in 1997 and the Total Labor Force (in %) of Central African Republic in 1999?
Your response must be concise. -19.86. What is the difference between the Total Labor Force (in %) of High income: OECD in 1997 and the Total Labor Force (in %) of Lower middle income in 1999?
Offer a terse response. 15.27. What is the difference between the Total Labor Force (in %) of High income: OECD in 1997 and the Total Labor Force (in %) of Central African Republic in 1999?
Your response must be concise. -8.66. What is the difference between the Total Labor Force (in %) in Lower middle income in 1997 and the Total Labor Force (in %) in Central African Republic in 1999?
Keep it short and to the point. -23.5. What is the difference between the Total Labor Force (in %) of Europe(developing only) in 1997 and the Total Labor Force (in %) of High income: OECD in 2000?
Your answer should be very brief. -11.52. What is the difference between the Total Labor Force (in %) in Europe(developing only) in 1997 and the Total Labor Force (in %) in Lower middle income in 2000?
Offer a terse response. 4.66. What is the difference between the Total Labor Force (in %) of Europe(developing only) in 1997 and the Total Labor Force (in %) of Central African Republic in 2000?
Keep it short and to the point. -19.86. What is the difference between the Total Labor Force (in %) in High income: OECD in 1997 and the Total Labor Force (in %) in Lower middle income in 2000?
Provide a short and direct response. 15.86. What is the difference between the Total Labor Force (in %) of High income: OECD in 1997 and the Total Labor Force (in %) of Central African Republic in 2000?
Your answer should be compact. -8.66. What is the difference between the Total Labor Force (in %) in Lower middle income in 1997 and the Total Labor Force (in %) in Central African Republic in 2000?
Make the answer very short. -23.5. What is the difference between the Total Labor Force (in %) of Europe(developing only) in 1998 and the Total Labor Force (in %) of High income: OECD in 1999?
Your answer should be compact. -11.92. What is the difference between the Total Labor Force (in %) in Europe(developing only) in 1998 and the Total Labor Force (in %) in Lower middle income in 1999?
Keep it short and to the point. 3.34. What is the difference between the Total Labor Force (in %) in Europe(developing only) in 1998 and the Total Labor Force (in %) in Central African Republic in 1999?
Provide a short and direct response. -20.58. What is the difference between the Total Labor Force (in %) in High income: OECD in 1998 and the Total Labor Force (in %) in Lower middle income in 1999?
Offer a terse response. 15.37. What is the difference between the Total Labor Force (in %) in High income: OECD in 1998 and the Total Labor Force (in %) in Central African Republic in 1999?
Keep it short and to the point. -8.55. What is the difference between the Total Labor Force (in %) of Lower middle income in 1998 and the Total Labor Force (in %) of Central African Republic in 1999?
Make the answer very short. -23.95. What is the difference between the Total Labor Force (in %) in Europe(developing only) in 1998 and the Total Labor Force (in %) in High income: OECD in 2000?
Your response must be concise. -12.24. What is the difference between the Total Labor Force (in %) of Europe(developing only) in 1998 and the Total Labor Force (in %) of Lower middle income in 2000?
Keep it short and to the point. 3.93. What is the difference between the Total Labor Force (in %) in Europe(developing only) in 1998 and the Total Labor Force (in %) in Central African Republic in 2000?
Make the answer very short. -20.58. What is the difference between the Total Labor Force (in %) in High income: OECD in 1998 and the Total Labor Force (in %) in Lower middle income in 2000?
Your answer should be compact. 15.96. What is the difference between the Total Labor Force (in %) of High income: OECD in 1998 and the Total Labor Force (in %) of Central African Republic in 2000?
Keep it short and to the point. -8.55. What is the difference between the Total Labor Force (in %) of Lower middle income in 1998 and the Total Labor Force (in %) of Central African Republic in 2000?
Offer a terse response. -23.95. What is the difference between the Total Labor Force (in %) of Europe(developing only) in 1999 and the Total Labor Force (in %) of High income: OECD in 2000?
Ensure brevity in your answer.  -12.29. What is the difference between the Total Labor Force (in %) in Europe(developing only) in 1999 and the Total Labor Force (in %) in Lower middle income in 2000?
Make the answer very short. 3.88. What is the difference between the Total Labor Force (in %) of Europe(developing only) in 1999 and the Total Labor Force (in %) of Central African Republic in 2000?
Offer a terse response. -20.64. What is the difference between the Total Labor Force (in %) in High income: OECD in 1999 and the Total Labor Force (in %) in Lower middle income in 2000?
Offer a terse response. 15.85. What is the difference between the Total Labor Force (in %) of High income: OECD in 1999 and the Total Labor Force (in %) of Central African Republic in 2000?
Your response must be concise. -8.66. What is the difference between the Total Labor Force (in %) of Lower middle income in 1999 and the Total Labor Force (in %) of Central African Republic in 2000?
Provide a succinct answer. -23.92. What is the average Total Labor Force (in %) in Europe(developing only) per year?
Keep it short and to the point. 37.86. What is the average Total Labor Force (in %) of High income: OECD per year?
Your response must be concise. 49.04. What is the average Total Labor Force (in %) of Lower middle income per year?
Offer a very short reply. 34.13. What is the average Total Labor Force (in %) in Central African Republic per year?
Your response must be concise. 57.52. In the year 1993, what is the difference between the Total Labor Force (in %) of Europe(developing only) and Total Labor Force (in %) of High income: OECD?
Keep it short and to the point. -10.35. In the year 1993, what is the difference between the Total Labor Force (in %) in Europe(developing only) and Total Labor Force (in %) in Lower middle income?
Your response must be concise. 4.04. In the year 1993, what is the difference between the Total Labor Force (in %) in Europe(developing only) and Total Labor Force (in %) in Central African Republic?
Give a very brief answer. -18.47. In the year 1993, what is the difference between the Total Labor Force (in %) in High income: OECD and Total Labor Force (in %) in Lower middle income?
Provide a short and direct response. 14.4. In the year 1993, what is the difference between the Total Labor Force (in %) of High income: OECD and Total Labor Force (in %) of Central African Republic?
Make the answer very short. -8.11. In the year 1993, what is the difference between the Total Labor Force (in %) of Lower middle income and Total Labor Force (in %) of Central African Republic?
Give a very brief answer. -22.51. In the year 1994, what is the difference between the Total Labor Force (in %) of Europe(developing only) and Total Labor Force (in %) of High income: OECD?
Your answer should be compact. -9.4. In the year 1994, what is the difference between the Total Labor Force (in %) in Europe(developing only) and Total Labor Force (in %) in Lower middle income?
Make the answer very short. 5.02. In the year 1994, what is the difference between the Total Labor Force (in %) of Europe(developing only) and Total Labor Force (in %) of Central African Republic?
Give a very brief answer. -17.49. In the year 1994, what is the difference between the Total Labor Force (in %) of High income: OECD and Total Labor Force (in %) of Lower middle income?
Offer a terse response. 14.41. In the year 1994, what is the difference between the Total Labor Force (in %) in High income: OECD and Total Labor Force (in %) in Central African Republic?
Give a very brief answer. -8.1. In the year 1994, what is the difference between the Total Labor Force (in %) of Lower middle income and Total Labor Force (in %) of Central African Republic?
Your answer should be very brief. -22.51. In the year 1995, what is the difference between the Total Labor Force (in %) in Europe(developing only) and Total Labor Force (in %) in High income: OECD?
Provide a succinct answer. -9.92. In the year 1995, what is the difference between the Total Labor Force (in %) in Europe(developing only) and Total Labor Force (in %) in Lower middle income?
Keep it short and to the point. 4.47. In the year 1995, what is the difference between the Total Labor Force (in %) of Europe(developing only) and Total Labor Force (in %) of Central African Republic?
Ensure brevity in your answer.  -18.48. In the year 1995, what is the difference between the Total Labor Force (in %) of High income: OECD and Total Labor Force (in %) of Lower middle income?
Ensure brevity in your answer.  14.39. In the year 1995, what is the difference between the Total Labor Force (in %) of High income: OECD and Total Labor Force (in %) of Central African Republic?
Give a very brief answer. -8.56. In the year 1995, what is the difference between the Total Labor Force (in %) of Lower middle income and Total Labor Force (in %) of Central African Republic?
Keep it short and to the point. -22.95. In the year 1996, what is the difference between the Total Labor Force (in %) in Europe(developing only) and Total Labor Force (in %) in High income: OECD?
Make the answer very short. -10.22. In the year 1996, what is the difference between the Total Labor Force (in %) of Europe(developing only) and Total Labor Force (in %) of Lower middle income?
Make the answer very short. 4.23. In the year 1996, what is the difference between the Total Labor Force (in %) of Europe(developing only) and Total Labor Force (in %) of Central African Republic?
Provide a short and direct response. -18.89. In the year 1996, what is the difference between the Total Labor Force (in %) of High income: OECD and Total Labor Force (in %) of Lower middle income?
Offer a very short reply. 14.44. In the year 1996, what is the difference between the Total Labor Force (in %) of High income: OECD and Total Labor Force (in %) of Central African Republic?
Keep it short and to the point. -8.67. In the year 1996, what is the difference between the Total Labor Force (in %) of Lower middle income and Total Labor Force (in %) of Central African Republic?
Provide a succinct answer. -23.12. In the year 1997, what is the difference between the Total Labor Force (in %) of Europe(developing only) and Total Labor Force (in %) of High income: OECD?
Give a very brief answer. -11.2. In the year 1997, what is the difference between the Total Labor Force (in %) of Europe(developing only) and Total Labor Force (in %) of Lower middle income?
Offer a terse response. 3.64. In the year 1997, what is the difference between the Total Labor Force (in %) in Europe(developing only) and Total Labor Force (in %) in Central African Republic?
Offer a terse response. -19.96. In the year 1997, what is the difference between the Total Labor Force (in %) in High income: OECD and Total Labor Force (in %) in Lower middle income?
Your answer should be very brief. 14.85. In the year 1997, what is the difference between the Total Labor Force (in %) of High income: OECD and Total Labor Force (in %) of Central African Republic?
Offer a very short reply. -8.76. In the year 1997, what is the difference between the Total Labor Force (in %) in Lower middle income and Total Labor Force (in %) in Central African Republic?
Provide a succinct answer. -23.6. In the year 1998, what is the difference between the Total Labor Force (in %) of Europe(developing only) and Total Labor Force (in %) of High income: OECD?
Provide a succinct answer. -12.03. In the year 1998, what is the difference between the Total Labor Force (in %) in Europe(developing only) and Total Labor Force (in %) in Lower middle income?
Provide a succinct answer. 3.37. In the year 1998, what is the difference between the Total Labor Force (in %) of Europe(developing only) and Total Labor Force (in %) of Central African Republic?
Your response must be concise. -20.68. In the year 1998, what is the difference between the Total Labor Force (in %) of High income: OECD and Total Labor Force (in %) of Lower middle income?
Provide a succinct answer. 15.4. In the year 1998, what is the difference between the Total Labor Force (in %) in High income: OECD and Total Labor Force (in %) in Central African Republic?
Provide a short and direct response. -8.65. In the year 1998, what is the difference between the Total Labor Force (in %) in Lower middle income and Total Labor Force (in %) in Central African Republic?
Your answer should be very brief. -24.05. In the year 1999, what is the difference between the Total Labor Force (in %) in Europe(developing only) and Total Labor Force (in %) in High income: OECD?
Provide a short and direct response. -11.98. In the year 1999, what is the difference between the Total Labor Force (in %) in Europe(developing only) and Total Labor Force (in %) in Lower middle income?
Keep it short and to the point. 3.29. In the year 1999, what is the difference between the Total Labor Force (in %) in Europe(developing only) and Total Labor Force (in %) in Central African Republic?
Offer a terse response. -20.64. In the year 1999, what is the difference between the Total Labor Force (in %) in High income: OECD and Total Labor Force (in %) in Lower middle income?
Offer a very short reply. 15.26. In the year 1999, what is the difference between the Total Labor Force (in %) in High income: OECD and Total Labor Force (in %) in Central African Republic?
Offer a terse response. -8.66. In the year 1999, what is the difference between the Total Labor Force (in %) in Lower middle income and Total Labor Force (in %) in Central African Republic?
Provide a succinct answer. -23.92. In the year 2000, what is the difference between the Total Labor Force (in %) of Europe(developing only) and Total Labor Force (in %) of High income: OECD?
Keep it short and to the point. -14.35. In the year 2000, what is the difference between the Total Labor Force (in %) of Europe(developing only) and Total Labor Force (in %) of Lower middle income?
Make the answer very short. 1.82. In the year 2000, what is the difference between the Total Labor Force (in %) in Europe(developing only) and Total Labor Force (in %) in Central African Republic?
Make the answer very short. -22.69. In the year 2000, what is the difference between the Total Labor Force (in %) of High income: OECD and Total Labor Force (in %) of Lower middle income?
Your response must be concise. 16.17. In the year 2000, what is the difference between the Total Labor Force (in %) in High income: OECD and Total Labor Force (in %) in Central African Republic?
Keep it short and to the point. -8.34. In the year 2000, what is the difference between the Total Labor Force (in %) of Lower middle income and Total Labor Force (in %) of Central African Republic?
Keep it short and to the point. -24.51. What is the ratio of the Total Labor Force (in %) in Europe(developing only) in 1993 to that in 1994?
Provide a succinct answer. 0.98. What is the ratio of the Total Labor Force (in %) of High income: OECD in 1993 to that in 1994?
Your answer should be very brief. 1. What is the ratio of the Total Labor Force (in %) of Lower middle income in 1993 to that in 1994?
Provide a short and direct response. 1. What is the ratio of the Total Labor Force (in %) of Europe(developing only) in 1993 to that in 1995?
Your response must be concise. 1. What is the ratio of the Total Labor Force (in %) in High income: OECD in 1993 to that in 1995?
Offer a very short reply. 1.01. What is the ratio of the Total Labor Force (in %) in Lower middle income in 1993 to that in 1995?
Provide a succinct answer. 1.02. What is the ratio of the Total Labor Force (in %) in Europe(developing only) in 1993 to that in 1996?
Your answer should be compact. 1.02. What is the ratio of the Total Labor Force (in %) of High income: OECD in 1993 to that in 1996?
Your answer should be very brief. 1.02. What is the ratio of the Total Labor Force (in %) of Lower middle income in 1993 to that in 1996?
Offer a very short reply. 1.02. What is the ratio of the Total Labor Force (in %) of Europe(developing only) in 1993 to that in 1997?
Your response must be concise. 1.04. What is the ratio of the Total Labor Force (in %) of High income: OECD in 1993 to that in 1997?
Your response must be concise. 1.02. What is the ratio of the Total Labor Force (in %) of Lower middle income in 1993 to that in 1997?
Offer a very short reply. 1.04. What is the ratio of the Total Labor Force (in %) of Europe(developing only) in 1993 to that in 1998?
Your answer should be very brief. 1.07. What is the ratio of the Total Labor Force (in %) of High income: OECD in 1993 to that in 1998?
Provide a short and direct response. 1.02. What is the ratio of the Total Labor Force (in %) in Lower middle income in 1993 to that in 1998?
Offer a terse response. 1.05. What is the ratio of the Total Labor Force (in %) in Central African Republic in 1993 to that in 1998?
Keep it short and to the point. 1. What is the ratio of the Total Labor Force (in %) of Europe(developing only) in 1993 to that in 1999?
Offer a terse response. 1.07. What is the ratio of the Total Labor Force (in %) of High income: OECD in 1993 to that in 1999?
Provide a succinct answer. 1.02. What is the ratio of the Total Labor Force (in %) of Lower middle income in 1993 to that in 1999?
Ensure brevity in your answer.  1.05. What is the ratio of the Total Labor Force (in %) in Central African Republic in 1993 to that in 1999?
Your answer should be compact. 1.01. What is the ratio of the Total Labor Force (in %) of Europe(developing only) in 1993 to that in 2000?
Your response must be concise. 1.13. What is the ratio of the Total Labor Force (in %) of High income: OECD in 1993 to that in 2000?
Provide a succinct answer. 1.01. What is the ratio of the Total Labor Force (in %) in Lower middle income in 1993 to that in 2000?
Make the answer very short. 1.07. What is the ratio of the Total Labor Force (in %) of Central African Republic in 1993 to that in 2000?
Ensure brevity in your answer.  1.01. What is the ratio of the Total Labor Force (in %) of Europe(developing only) in 1994 to that in 1995?
Your answer should be very brief. 1.03. What is the ratio of the Total Labor Force (in %) of High income: OECD in 1994 to that in 1995?
Your response must be concise. 1.01. What is the ratio of the Total Labor Force (in %) of Lower middle income in 1994 to that in 1995?
Offer a very short reply. 1.01. What is the ratio of the Total Labor Force (in %) in Central African Republic in 1994 to that in 1995?
Ensure brevity in your answer.  1. What is the ratio of the Total Labor Force (in %) of Europe(developing only) in 1994 to that in 1996?
Keep it short and to the point. 1.04. What is the ratio of the Total Labor Force (in %) of High income: OECD in 1994 to that in 1996?
Offer a terse response. 1.01. What is the ratio of the Total Labor Force (in %) of Lower middle income in 1994 to that in 1996?
Keep it short and to the point. 1.02. What is the ratio of the Total Labor Force (in %) of Europe(developing only) in 1994 to that in 1997?
Offer a very short reply. 1.07. What is the ratio of the Total Labor Force (in %) in High income: OECD in 1994 to that in 1997?
Your answer should be compact. 1.02. What is the ratio of the Total Labor Force (in %) of Lower middle income in 1994 to that in 1997?
Your answer should be very brief. 1.04. What is the ratio of the Total Labor Force (in %) of Europe(developing only) in 1994 to that in 1998?
Offer a terse response. 1.09. What is the ratio of the Total Labor Force (in %) of High income: OECD in 1994 to that in 1998?
Your answer should be compact. 1.01. What is the ratio of the Total Labor Force (in %) of Lower middle income in 1994 to that in 1998?
Keep it short and to the point. 1.05. What is the ratio of the Total Labor Force (in %) in Central African Republic in 1994 to that in 1998?
Provide a succinct answer. 1. What is the ratio of the Total Labor Force (in %) in Europe(developing only) in 1994 to that in 1999?
Offer a terse response. 1.09. What is the ratio of the Total Labor Force (in %) of High income: OECD in 1994 to that in 1999?
Your answer should be compact. 1.02. What is the ratio of the Total Labor Force (in %) in Lower middle income in 1994 to that in 1999?
Make the answer very short. 1.05. What is the ratio of the Total Labor Force (in %) in Europe(developing only) in 1994 to that in 2000?
Provide a succinct answer. 1.16. What is the ratio of the Total Labor Force (in %) of High income: OECD in 1994 to that in 2000?
Provide a short and direct response. 1.01. What is the ratio of the Total Labor Force (in %) of Lower middle income in 1994 to that in 2000?
Your answer should be compact. 1.07. What is the ratio of the Total Labor Force (in %) of Europe(developing only) in 1995 to that in 1996?
Keep it short and to the point. 1.01. What is the ratio of the Total Labor Force (in %) in High income: OECD in 1995 to that in 1996?
Keep it short and to the point. 1. What is the ratio of the Total Labor Force (in %) in Lower middle income in 1995 to that in 1996?
Offer a very short reply. 1.01. What is the ratio of the Total Labor Force (in %) of Central African Republic in 1995 to that in 1996?
Provide a succinct answer. 1. What is the ratio of the Total Labor Force (in %) of Europe(developing only) in 1995 to that in 1997?
Give a very brief answer. 1.04. What is the ratio of the Total Labor Force (in %) of Lower middle income in 1995 to that in 1997?
Your response must be concise. 1.02. What is the ratio of the Total Labor Force (in %) in Central African Republic in 1995 to that in 1997?
Your answer should be compact. 1. What is the ratio of the Total Labor Force (in %) of Europe(developing only) in 1995 to that in 1998?
Offer a terse response. 1.06. What is the ratio of the Total Labor Force (in %) in Lower middle income in 1995 to that in 1998?
Provide a short and direct response. 1.04. What is the ratio of the Total Labor Force (in %) in Central African Republic in 1995 to that in 1998?
Make the answer very short. 1. What is the ratio of the Total Labor Force (in %) of Europe(developing only) in 1995 to that in 1999?
Offer a very short reply. 1.06. What is the ratio of the Total Labor Force (in %) of Lower middle income in 1995 to that in 1999?
Provide a short and direct response. 1.03. What is the ratio of the Total Labor Force (in %) of Central African Republic in 1995 to that in 1999?
Your response must be concise. 1. What is the ratio of the Total Labor Force (in %) of Europe(developing only) in 1995 to that in 2000?
Offer a very short reply. 1.13. What is the ratio of the Total Labor Force (in %) of High income: OECD in 1995 to that in 2000?
Make the answer very short. 1. What is the ratio of the Total Labor Force (in %) in Lower middle income in 1995 to that in 2000?
Your answer should be compact. 1.05. What is the ratio of the Total Labor Force (in %) of Central African Republic in 1995 to that in 2000?
Your response must be concise. 1. What is the ratio of the Total Labor Force (in %) in Europe(developing only) in 1996 to that in 1997?
Your response must be concise. 1.03. What is the ratio of the Total Labor Force (in %) in Lower middle income in 1996 to that in 1997?
Give a very brief answer. 1.01. What is the ratio of the Total Labor Force (in %) of Europe(developing only) in 1996 to that in 1998?
Provide a short and direct response. 1.05. What is the ratio of the Total Labor Force (in %) in Lower middle income in 1996 to that in 1998?
Give a very brief answer. 1.03. What is the ratio of the Total Labor Force (in %) of Central African Republic in 1996 to that in 1998?
Offer a terse response. 1. What is the ratio of the Total Labor Force (in %) of Europe(developing only) in 1996 to that in 1999?
Provide a succinct answer. 1.05. What is the ratio of the Total Labor Force (in %) in High income: OECD in 1996 to that in 1999?
Offer a very short reply. 1. What is the ratio of the Total Labor Force (in %) in Lower middle income in 1996 to that in 1999?
Give a very brief answer. 1.03. What is the ratio of the Total Labor Force (in %) in Central African Republic in 1996 to that in 1999?
Ensure brevity in your answer.  1. What is the ratio of the Total Labor Force (in %) in Europe(developing only) in 1996 to that in 2000?
Offer a very short reply. 1.11. What is the ratio of the Total Labor Force (in %) of High income: OECD in 1996 to that in 2000?
Offer a terse response. 1. What is the ratio of the Total Labor Force (in %) in Lower middle income in 1996 to that in 2000?
Ensure brevity in your answer.  1.05. What is the ratio of the Total Labor Force (in %) of Europe(developing only) in 1997 to that in 1998?
Your response must be concise. 1.02. What is the ratio of the Total Labor Force (in %) of High income: OECD in 1997 to that in 1998?
Your answer should be compact. 1. What is the ratio of the Total Labor Force (in %) in Lower middle income in 1997 to that in 1998?
Your answer should be very brief. 1.01. What is the ratio of the Total Labor Force (in %) in Europe(developing only) in 1997 to that in 1999?
Your answer should be compact. 1.02. What is the ratio of the Total Labor Force (in %) in Lower middle income in 1997 to that in 1999?
Offer a very short reply. 1.01. What is the ratio of the Total Labor Force (in %) in Europe(developing only) in 1997 to that in 2000?
Your answer should be compact. 1.08. What is the ratio of the Total Labor Force (in %) in High income: OECD in 1997 to that in 2000?
Provide a succinct answer. 0.99. What is the ratio of the Total Labor Force (in %) of Lower middle income in 1997 to that in 2000?
Give a very brief answer. 1.03. What is the ratio of the Total Labor Force (in %) in Europe(developing only) in 1998 to that in 1999?
Provide a short and direct response. 1. What is the ratio of the Total Labor Force (in %) of Europe(developing only) in 1998 to that in 2000?
Provide a short and direct response. 1.06. What is the ratio of the Total Labor Force (in %) of High income: OECD in 1998 to that in 2000?
Keep it short and to the point. 1. What is the ratio of the Total Labor Force (in %) of Lower middle income in 1998 to that in 2000?
Provide a succinct answer. 1.02. What is the ratio of the Total Labor Force (in %) in Central African Republic in 1998 to that in 2000?
Give a very brief answer. 1. What is the ratio of the Total Labor Force (in %) of Europe(developing only) in 1999 to that in 2000?
Make the answer very short. 1.06. What is the ratio of the Total Labor Force (in %) of Lower middle income in 1999 to that in 2000?
Your response must be concise. 1.02. What is the difference between the highest and the second highest Total Labor Force (in %) in Europe(developing only)?
Make the answer very short. 0.87. What is the difference between the highest and the second highest Total Labor Force (in %) in High income: OECD?
Offer a very short reply. 0.08. What is the difference between the highest and the second highest Total Labor Force (in %) of Lower middle income?
Your response must be concise. 0.1. What is the difference between the highest and the lowest Total Labor Force (in %) in Europe(developing only)?
Offer a terse response. 5.4. What is the difference between the highest and the lowest Total Labor Force (in %) in High income: OECD?
Make the answer very short. 0.85. What is the difference between the highest and the lowest Total Labor Force (in %) in Lower middle income?
Ensure brevity in your answer.  2.3. 